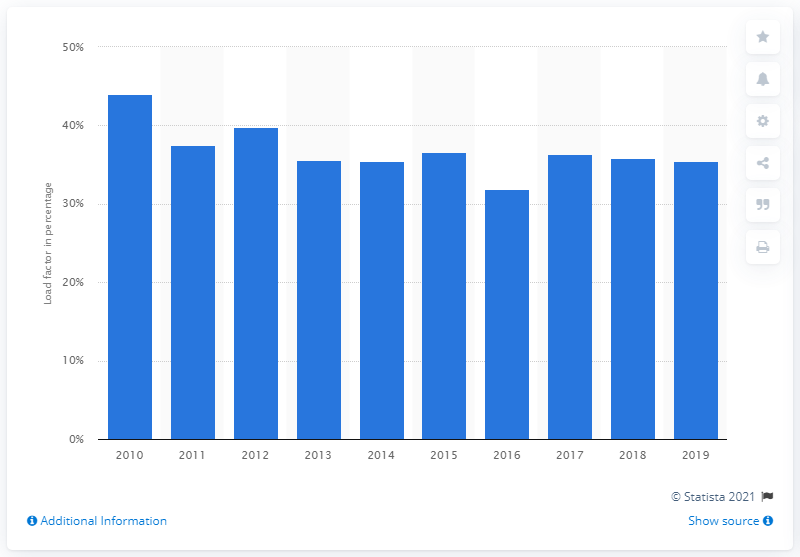Highlight a few significant elements in this photo. The load factor for electricity generation from waste energy in the UK began to fluctuate in 2010. In 2019, the load factor of energy from waste in the UK was 35.4%. The average load factor of energy from waste in the period of consideration was 36.6%. 